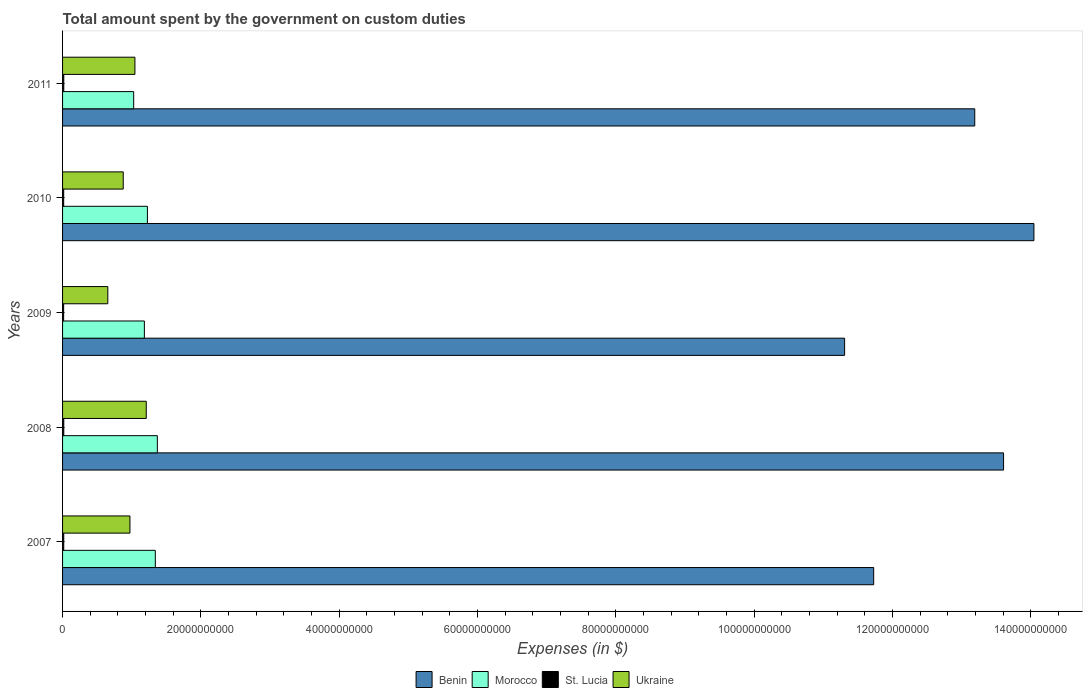How many bars are there on the 3rd tick from the top?
Keep it short and to the point. 4. How many bars are there on the 5th tick from the bottom?
Make the answer very short. 4. What is the amount spent on custom duties by the government in Benin in 2009?
Offer a very short reply. 1.13e+11. Across all years, what is the maximum amount spent on custom duties by the government in St. Lucia?
Your answer should be very brief. 1.75e+08. Across all years, what is the minimum amount spent on custom duties by the government in St. Lucia?
Give a very brief answer. 1.55e+08. In which year was the amount spent on custom duties by the government in Morocco maximum?
Your response must be concise. 2008. What is the total amount spent on custom duties by the government in Ukraine in the graph?
Ensure brevity in your answer.  4.76e+1. What is the difference between the amount spent on custom duties by the government in Morocco in 2007 and that in 2009?
Your answer should be compact. 1.59e+09. What is the difference between the amount spent on custom duties by the government in Benin in 2010 and the amount spent on custom duties by the government in St. Lucia in 2011?
Your response must be concise. 1.40e+11. What is the average amount spent on custom duties by the government in Morocco per year?
Ensure brevity in your answer.  1.23e+1. In the year 2007, what is the difference between the amount spent on custom duties by the government in St. Lucia and amount spent on custom duties by the government in Benin?
Keep it short and to the point. -1.17e+11. In how many years, is the amount spent on custom duties by the government in Ukraine greater than 84000000000 $?
Provide a succinct answer. 0. What is the ratio of the amount spent on custom duties by the government in Morocco in 2008 to that in 2009?
Keep it short and to the point. 1.16. Is the amount spent on custom duties by the government in Benin in 2007 less than that in 2009?
Ensure brevity in your answer.  No. Is the difference between the amount spent on custom duties by the government in St. Lucia in 2007 and 2011 greater than the difference between the amount spent on custom duties by the government in Benin in 2007 and 2011?
Give a very brief answer. Yes. What is the difference between the highest and the second highest amount spent on custom duties by the government in Morocco?
Provide a short and direct response. 2.91e+08. What is the difference between the highest and the lowest amount spent on custom duties by the government in Ukraine?
Provide a short and direct response. 5.56e+09. Is the sum of the amount spent on custom duties by the government in Morocco in 2008 and 2009 greater than the maximum amount spent on custom duties by the government in Benin across all years?
Provide a succinct answer. No. What does the 3rd bar from the top in 2011 represents?
Provide a succinct answer. Morocco. What does the 3rd bar from the bottom in 2009 represents?
Ensure brevity in your answer.  St. Lucia. Is it the case that in every year, the sum of the amount spent on custom duties by the government in St. Lucia and amount spent on custom duties by the government in Morocco is greater than the amount spent on custom duties by the government in Benin?
Provide a short and direct response. No. How many bars are there?
Ensure brevity in your answer.  20. Are all the bars in the graph horizontal?
Provide a short and direct response. Yes. What is the difference between two consecutive major ticks on the X-axis?
Give a very brief answer. 2.00e+1. Where does the legend appear in the graph?
Make the answer very short. Bottom center. How are the legend labels stacked?
Your response must be concise. Horizontal. What is the title of the graph?
Your response must be concise. Total amount spent by the government on custom duties. What is the label or title of the X-axis?
Offer a terse response. Expenses (in $). What is the label or title of the Y-axis?
Your answer should be very brief. Years. What is the Expenses (in $) of Benin in 2007?
Keep it short and to the point. 1.17e+11. What is the Expenses (in $) in Morocco in 2007?
Your answer should be compact. 1.34e+1. What is the Expenses (in $) in St. Lucia in 2007?
Provide a succinct answer. 1.72e+08. What is the Expenses (in $) of Ukraine in 2007?
Provide a succinct answer. 9.74e+09. What is the Expenses (in $) of Benin in 2008?
Keep it short and to the point. 1.36e+11. What is the Expenses (in $) in Morocco in 2008?
Provide a succinct answer. 1.37e+1. What is the Expenses (in $) in St. Lucia in 2008?
Your answer should be compact. 1.75e+08. What is the Expenses (in $) of Ukraine in 2008?
Your answer should be compact. 1.21e+1. What is the Expenses (in $) in Benin in 2009?
Make the answer very short. 1.13e+11. What is the Expenses (in $) in Morocco in 2009?
Your answer should be very brief. 1.18e+1. What is the Expenses (in $) of St. Lucia in 2009?
Provide a short and direct response. 1.55e+08. What is the Expenses (in $) of Ukraine in 2009?
Provide a short and direct response. 6.54e+09. What is the Expenses (in $) of Benin in 2010?
Offer a very short reply. 1.40e+11. What is the Expenses (in $) in Morocco in 2010?
Keep it short and to the point. 1.23e+1. What is the Expenses (in $) of St. Lucia in 2010?
Give a very brief answer. 1.61e+08. What is the Expenses (in $) of Ukraine in 2010?
Give a very brief answer. 8.77e+09. What is the Expenses (in $) of Benin in 2011?
Offer a very short reply. 1.32e+11. What is the Expenses (in $) of Morocco in 2011?
Offer a terse response. 1.03e+1. What is the Expenses (in $) in St. Lucia in 2011?
Ensure brevity in your answer.  1.75e+08. What is the Expenses (in $) in Ukraine in 2011?
Offer a terse response. 1.05e+1. Across all years, what is the maximum Expenses (in $) in Benin?
Keep it short and to the point. 1.40e+11. Across all years, what is the maximum Expenses (in $) in Morocco?
Give a very brief answer. 1.37e+1. Across all years, what is the maximum Expenses (in $) of St. Lucia?
Give a very brief answer. 1.75e+08. Across all years, what is the maximum Expenses (in $) of Ukraine?
Ensure brevity in your answer.  1.21e+1. Across all years, what is the minimum Expenses (in $) in Benin?
Ensure brevity in your answer.  1.13e+11. Across all years, what is the minimum Expenses (in $) of Morocco?
Give a very brief answer. 1.03e+1. Across all years, what is the minimum Expenses (in $) of St. Lucia?
Make the answer very short. 1.55e+08. Across all years, what is the minimum Expenses (in $) of Ukraine?
Provide a short and direct response. 6.54e+09. What is the total Expenses (in $) of Benin in the graph?
Offer a very short reply. 6.39e+11. What is the total Expenses (in $) of Morocco in the graph?
Give a very brief answer. 6.15e+1. What is the total Expenses (in $) of St. Lucia in the graph?
Offer a terse response. 8.38e+08. What is the total Expenses (in $) of Ukraine in the graph?
Give a very brief answer. 4.76e+1. What is the difference between the Expenses (in $) of Benin in 2007 and that in 2008?
Your answer should be very brief. -1.88e+1. What is the difference between the Expenses (in $) of Morocco in 2007 and that in 2008?
Offer a terse response. -2.91e+08. What is the difference between the Expenses (in $) of St. Lucia in 2007 and that in 2008?
Ensure brevity in your answer.  -3.30e+06. What is the difference between the Expenses (in $) of Ukraine in 2007 and that in 2008?
Make the answer very short. -2.36e+09. What is the difference between the Expenses (in $) in Benin in 2007 and that in 2009?
Offer a very short reply. 4.21e+09. What is the difference between the Expenses (in $) of Morocco in 2007 and that in 2009?
Ensure brevity in your answer.  1.59e+09. What is the difference between the Expenses (in $) of St. Lucia in 2007 and that in 2009?
Give a very brief answer. 1.72e+07. What is the difference between the Expenses (in $) of Ukraine in 2007 and that in 2009?
Offer a terse response. 3.20e+09. What is the difference between the Expenses (in $) of Benin in 2007 and that in 2010?
Your answer should be very brief. -2.32e+1. What is the difference between the Expenses (in $) in Morocco in 2007 and that in 2010?
Provide a succinct answer. 1.15e+09. What is the difference between the Expenses (in $) of St. Lucia in 2007 and that in 2010?
Offer a terse response. 1.10e+07. What is the difference between the Expenses (in $) in Ukraine in 2007 and that in 2010?
Provide a short and direct response. 9.71e+08. What is the difference between the Expenses (in $) in Benin in 2007 and that in 2011?
Make the answer very short. -1.46e+1. What is the difference between the Expenses (in $) in Morocco in 2007 and that in 2011?
Your response must be concise. 3.13e+09. What is the difference between the Expenses (in $) in St. Lucia in 2007 and that in 2011?
Make the answer very short. -2.60e+06. What is the difference between the Expenses (in $) in Ukraine in 2007 and that in 2011?
Provide a short and direct response. -7.19e+08. What is the difference between the Expenses (in $) in Benin in 2008 and that in 2009?
Give a very brief answer. 2.30e+1. What is the difference between the Expenses (in $) of Morocco in 2008 and that in 2009?
Offer a terse response. 1.88e+09. What is the difference between the Expenses (in $) in St. Lucia in 2008 and that in 2009?
Make the answer very short. 2.05e+07. What is the difference between the Expenses (in $) of Ukraine in 2008 and that in 2009?
Your answer should be very brief. 5.56e+09. What is the difference between the Expenses (in $) of Benin in 2008 and that in 2010?
Keep it short and to the point. -4.39e+09. What is the difference between the Expenses (in $) of Morocco in 2008 and that in 2010?
Give a very brief answer. 1.44e+09. What is the difference between the Expenses (in $) of St. Lucia in 2008 and that in 2010?
Your answer should be very brief. 1.43e+07. What is the difference between the Expenses (in $) in Ukraine in 2008 and that in 2010?
Keep it short and to the point. 3.33e+09. What is the difference between the Expenses (in $) in Benin in 2008 and that in 2011?
Your answer should be very brief. 4.17e+09. What is the difference between the Expenses (in $) of Morocco in 2008 and that in 2011?
Keep it short and to the point. 3.42e+09. What is the difference between the Expenses (in $) of Ukraine in 2008 and that in 2011?
Offer a very short reply. 1.64e+09. What is the difference between the Expenses (in $) in Benin in 2009 and that in 2010?
Keep it short and to the point. -2.74e+1. What is the difference between the Expenses (in $) of Morocco in 2009 and that in 2010?
Your response must be concise. -4.39e+08. What is the difference between the Expenses (in $) in St. Lucia in 2009 and that in 2010?
Keep it short and to the point. -6.20e+06. What is the difference between the Expenses (in $) of Ukraine in 2009 and that in 2010?
Make the answer very short. -2.23e+09. What is the difference between the Expenses (in $) of Benin in 2009 and that in 2011?
Provide a short and direct response. -1.88e+1. What is the difference between the Expenses (in $) in Morocco in 2009 and that in 2011?
Give a very brief answer. 1.54e+09. What is the difference between the Expenses (in $) of St. Lucia in 2009 and that in 2011?
Your answer should be compact. -1.98e+07. What is the difference between the Expenses (in $) of Ukraine in 2009 and that in 2011?
Your response must be concise. -3.92e+09. What is the difference between the Expenses (in $) in Benin in 2010 and that in 2011?
Offer a terse response. 8.56e+09. What is the difference between the Expenses (in $) in Morocco in 2010 and that in 2011?
Offer a very short reply. 1.98e+09. What is the difference between the Expenses (in $) in St. Lucia in 2010 and that in 2011?
Give a very brief answer. -1.36e+07. What is the difference between the Expenses (in $) in Ukraine in 2010 and that in 2011?
Your answer should be compact. -1.69e+09. What is the difference between the Expenses (in $) in Benin in 2007 and the Expenses (in $) in Morocco in 2008?
Offer a terse response. 1.04e+11. What is the difference between the Expenses (in $) of Benin in 2007 and the Expenses (in $) of St. Lucia in 2008?
Your answer should be very brief. 1.17e+11. What is the difference between the Expenses (in $) in Benin in 2007 and the Expenses (in $) in Ukraine in 2008?
Your response must be concise. 1.05e+11. What is the difference between the Expenses (in $) in Morocco in 2007 and the Expenses (in $) in St. Lucia in 2008?
Provide a short and direct response. 1.32e+1. What is the difference between the Expenses (in $) of Morocco in 2007 and the Expenses (in $) of Ukraine in 2008?
Give a very brief answer. 1.31e+09. What is the difference between the Expenses (in $) of St. Lucia in 2007 and the Expenses (in $) of Ukraine in 2008?
Ensure brevity in your answer.  -1.19e+1. What is the difference between the Expenses (in $) of Benin in 2007 and the Expenses (in $) of Morocco in 2009?
Your answer should be compact. 1.05e+11. What is the difference between the Expenses (in $) of Benin in 2007 and the Expenses (in $) of St. Lucia in 2009?
Your answer should be compact. 1.17e+11. What is the difference between the Expenses (in $) of Benin in 2007 and the Expenses (in $) of Ukraine in 2009?
Provide a short and direct response. 1.11e+11. What is the difference between the Expenses (in $) in Morocco in 2007 and the Expenses (in $) in St. Lucia in 2009?
Ensure brevity in your answer.  1.33e+1. What is the difference between the Expenses (in $) in Morocco in 2007 and the Expenses (in $) in Ukraine in 2009?
Your response must be concise. 6.87e+09. What is the difference between the Expenses (in $) of St. Lucia in 2007 and the Expenses (in $) of Ukraine in 2009?
Your answer should be compact. -6.37e+09. What is the difference between the Expenses (in $) of Benin in 2007 and the Expenses (in $) of Morocco in 2010?
Ensure brevity in your answer.  1.05e+11. What is the difference between the Expenses (in $) of Benin in 2007 and the Expenses (in $) of St. Lucia in 2010?
Make the answer very short. 1.17e+11. What is the difference between the Expenses (in $) of Benin in 2007 and the Expenses (in $) of Ukraine in 2010?
Your answer should be very brief. 1.09e+11. What is the difference between the Expenses (in $) of Morocco in 2007 and the Expenses (in $) of St. Lucia in 2010?
Provide a succinct answer. 1.33e+1. What is the difference between the Expenses (in $) of Morocco in 2007 and the Expenses (in $) of Ukraine in 2010?
Keep it short and to the point. 4.64e+09. What is the difference between the Expenses (in $) in St. Lucia in 2007 and the Expenses (in $) in Ukraine in 2010?
Keep it short and to the point. -8.60e+09. What is the difference between the Expenses (in $) of Benin in 2007 and the Expenses (in $) of Morocco in 2011?
Provide a succinct answer. 1.07e+11. What is the difference between the Expenses (in $) in Benin in 2007 and the Expenses (in $) in St. Lucia in 2011?
Ensure brevity in your answer.  1.17e+11. What is the difference between the Expenses (in $) of Benin in 2007 and the Expenses (in $) of Ukraine in 2011?
Make the answer very short. 1.07e+11. What is the difference between the Expenses (in $) of Morocco in 2007 and the Expenses (in $) of St. Lucia in 2011?
Offer a very short reply. 1.32e+1. What is the difference between the Expenses (in $) of Morocco in 2007 and the Expenses (in $) of Ukraine in 2011?
Give a very brief answer. 2.95e+09. What is the difference between the Expenses (in $) in St. Lucia in 2007 and the Expenses (in $) in Ukraine in 2011?
Make the answer very short. -1.03e+1. What is the difference between the Expenses (in $) of Benin in 2008 and the Expenses (in $) of Morocco in 2009?
Make the answer very short. 1.24e+11. What is the difference between the Expenses (in $) in Benin in 2008 and the Expenses (in $) in St. Lucia in 2009?
Your answer should be compact. 1.36e+11. What is the difference between the Expenses (in $) of Benin in 2008 and the Expenses (in $) of Ukraine in 2009?
Ensure brevity in your answer.  1.30e+11. What is the difference between the Expenses (in $) in Morocco in 2008 and the Expenses (in $) in St. Lucia in 2009?
Your answer should be very brief. 1.36e+1. What is the difference between the Expenses (in $) in Morocco in 2008 and the Expenses (in $) in Ukraine in 2009?
Your answer should be very brief. 7.16e+09. What is the difference between the Expenses (in $) of St. Lucia in 2008 and the Expenses (in $) of Ukraine in 2009?
Ensure brevity in your answer.  -6.37e+09. What is the difference between the Expenses (in $) in Benin in 2008 and the Expenses (in $) in Morocco in 2010?
Keep it short and to the point. 1.24e+11. What is the difference between the Expenses (in $) in Benin in 2008 and the Expenses (in $) in St. Lucia in 2010?
Ensure brevity in your answer.  1.36e+11. What is the difference between the Expenses (in $) in Benin in 2008 and the Expenses (in $) in Ukraine in 2010?
Provide a succinct answer. 1.27e+11. What is the difference between the Expenses (in $) in Morocco in 2008 and the Expenses (in $) in St. Lucia in 2010?
Provide a short and direct response. 1.35e+1. What is the difference between the Expenses (in $) of Morocco in 2008 and the Expenses (in $) of Ukraine in 2010?
Your answer should be very brief. 4.93e+09. What is the difference between the Expenses (in $) in St. Lucia in 2008 and the Expenses (in $) in Ukraine in 2010?
Offer a terse response. -8.60e+09. What is the difference between the Expenses (in $) of Benin in 2008 and the Expenses (in $) of Morocco in 2011?
Offer a terse response. 1.26e+11. What is the difference between the Expenses (in $) of Benin in 2008 and the Expenses (in $) of St. Lucia in 2011?
Provide a succinct answer. 1.36e+11. What is the difference between the Expenses (in $) of Benin in 2008 and the Expenses (in $) of Ukraine in 2011?
Give a very brief answer. 1.26e+11. What is the difference between the Expenses (in $) of Morocco in 2008 and the Expenses (in $) of St. Lucia in 2011?
Make the answer very short. 1.35e+1. What is the difference between the Expenses (in $) in Morocco in 2008 and the Expenses (in $) in Ukraine in 2011?
Keep it short and to the point. 3.24e+09. What is the difference between the Expenses (in $) of St. Lucia in 2008 and the Expenses (in $) of Ukraine in 2011?
Provide a short and direct response. -1.03e+1. What is the difference between the Expenses (in $) of Benin in 2009 and the Expenses (in $) of Morocco in 2010?
Ensure brevity in your answer.  1.01e+11. What is the difference between the Expenses (in $) in Benin in 2009 and the Expenses (in $) in St. Lucia in 2010?
Ensure brevity in your answer.  1.13e+11. What is the difference between the Expenses (in $) of Benin in 2009 and the Expenses (in $) of Ukraine in 2010?
Make the answer very short. 1.04e+11. What is the difference between the Expenses (in $) of Morocco in 2009 and the Expenses (in $) of St. Lucia in 2010?
Your response must be concise. 1.17e+1. What is the difference between the Expenses (in $) in Morocco in 2009 and the Expenses (in $) in Ukraine in 2010?
Offer a terse response. 3.06e+09. What is the difference between the Expenses (in $) in St. Lucia in 2009 and the Expenses (in $) in Ukraine in 2010?
Your answer should be very brief. -8.62e+09. What is the difference between the Expenses (in $) in Benin in 2009 and the Expenses (in $) in Morocco in 2011?
Provide a succinct answer. 1.03e+11. What is the difference between the Expenses (in $) in Benin in 2009 and the Expenses (in $) in St. Lucia in 2011?
Keep it short and to the point. 1.13e+11. What is the difference between the Expenses (in $) of Benin in 2009 and the Expenses (in $) of Ukraine in 2011?
Give a very brief answer. 1.03e+11. What is the difference between the Expenses (in $) of Morocco in 2009 and the Expenses (in $) of St. Lucia in 2011?
Make the answer very short. 1.17e+1. What is the difference between the Expenses (in $) in Morocco in 2009 and the Expenses (in $) in Ukraine in 2011?
Offer a terse response. 1.37e+09. What is the difference between the Expenses (in $) of St. Lucia in 2009 and the Expenses (in $) of Ukraine in 2011?
Ensure brevity in your answer.  -1.03e+1. What is the difference between the Expenses (in $) of Benin in 2010 and the Expenses (in $) of Morocco in 2011?
Ensure brevity in your answer.  1.30e+11. What is the difference between the Expenses (in $) in Benin in 2010 and the Expenses (in $) in St. Lucia in 2011?
Provide a succinct answer. 1.40e+11. What is the difference between the Expenses (in $) in Benin in 2010 and the Expenses (in $) in Ukraine in 2011?
Keep it short and to the point. 1.30e+11. What is the difference between the Expenses (in $) in Morocco in 2010 and the Expenses (in $) in St. Lucia in 2011?
Give a very brief answer. 1.21e+1. What is the difference between the Expenses (in $) in Morocco in 2010 and the Expenses (in $) in Ukraine in 2011?
Offer a terse response. 1.81e+09. What is the difference between the Expenses (in $) of St. Lucia in 2010 and the Expenses (in $) of Ukraine in 2011?
Give a very brief answer. -1.03e+1. What is the average Expenses (in $) in Benin per year?
Your response must be concise. 1.28e+11. What is the average Expenses (in $) of Morocco per year?
Give a very brief answer. 1.23e+1. What is the average Expenses (in $) in St. Lucia per year?
Ensure brevity in your answer.  1.68e+08. What is the average Expenses (in $) in Ukraine per year?
Your response must be concise. 9.52e+09. In the year 2007, what is the difference between the Expenses (in $) in Benin and Expenses (in $) in Morocco?
Offer a terse response. 1.04e+11. In the year 2007, what is the difference between the Expenses (in $) in Benin and Expenses (in $) in St. Lucia?
Offer a terse response. 1.17e+11. In the year 2007, what is the difference between the Expenses (in $) in Benin and Expenses (in $) in Ukraine?
Provide a succinct answer. 1.08e+11. In the year 2007, what is the difference between the Expenses (in $) in Morocco and Expenses (in $) in St. Lucia?
Provide a succinct answer. 1.32e+1. In the year 2007, what is the difference between the Expenses (in $) in Morocco and Expenses (in $) in Ukraine?
Make the answer very short. 3.67e+09. In the year 2007, what is the difference between the Expenses (in $) in St. Lucia and Expenses (in $) in Ukraine?
Your answer should be very brief. -9.57e+09. In the year 2008, what is the difference between the Expenses (in $) in Benin and Expenses (in $) in Morocco?
Give a very brief answer. 1.22e+11. In the year 2008, what is the difference between the Expenses (in $) of Benin and Expenses (in $) of St. Lucia?
Give a very brief answer. 1.36e+11. In the year 2008, what is the difference between the Expenses (in $) of Benin and Expenses (in $) of Ukraine?
Your answer should be compact. 1.24e+11. In the year 2008, what is the difference between the Expenses (in $) in Morocco and Expenses (in $) in St. Lucia?
Keep it short and to the point. 1.35e+1. In the year 2008, what is the difference between the Expenses (in $) in Morocco and Expenses (in $) in Ukraine?
Provide a succinct answer. 1.60e+09. In the year 2008, what is the difference between the Expenses (in $) of St. Lucia and Expenses (in $) of Ukraine?
Keep it short and to the point. -1.19e+1. In the year 2009, what is the difference between the Expenses (in $) in Benin and Expenses (in $) in Morocco?
Keep it short and to the point. 1.01e+11. In the year 2009, what is the difference between the Expenses (in $) in Benin and Expenses (in $) in St. Lucia?
Offer a terse response. 1.13e+11. In the year 2009, what is the difference between the Expenses (in $) in Benin and Expenses (in $) in Ukraine?
Ensure brevity in your answer.  1.07e+11. In the year 2009, what is the difference between the Expenses (in $) of Morocco and Expenses (in $) of St. Lucia?
Offer a terse response. 1.17e+1. In the year 2009, what is the difference between the Expenses (in $) in Morocco and Expenses (in $) in Ukraine?
Your answer should be very brief. 5.29e+09. In the year 2009, what is the difference between the Expenses (in $) of St. Lucia and Expenses (in $) of Ukraine?
Make the answer very short. -6.39e+09. In the year 2010, what is the difference between the Expenses (in $) of Benin and Expenses (in $) of Morocco?
Provide a succinct answer. 1.28e+11. In the year 2010, what is the difference between the Expenses (in $) of Benin and Expenses (in $) of St. Lucia?
Provide a short and direct response. 1.40e+11. In the year 2010, what is the difference between the Expenses (in $) of Benin and Expenses (in $) of Ukraine?
Offer a very short reply. 1.32e+11. In the year 2010, what is the difference between the Expenses (in $) of Morocco and Expenses (in $) of St. Lucia?
Provide a succinct answer. 1.21e+1. In the year 2010, what is the difference between the Expenses (in $) in Morocco and Expenses (in $) in Ukraine?
Provide a short and direct response. 3.50e+09. In the year 2010, what is the difference between the Expenses (in $) in St. Lucia and Expenses (in $) in Ukraine?
Make the answer very short. -8.61e+09. In the year 2011, what is the difference between the Expenses (in $) in Benin and Expenses (in $) in Morocco?
Provide a succinct answer. 1.22e+11. In the year 2011, what is the difference between the Expenses (in $) in Benin and Expenses (in $) in St. Lucia?
Give a very brief answer. 1.32e+11. In the year 2011, what is the difference between the Expenses (in $) in Benin and Expenses (in $) in Ukraine?
Your answer should be very brief. 1.21e+11. In the year 2011, what is the difference between the Expenses (in $) of Morocco and Expenses (in $) of St. Lucia?
Keep it short and to the point. 1.01e+1. In the year 2011, what is the difference between the Expenses (in $) of Morocco and Expenses (in $) of Ukraine?
Your answer should be very brief. -1.77e+08. In the year 2011, what is the difference between the Expenses (in $) in St. Lucia and Expenses (in $) in Ukraine?
Make the answer very short. -1.03e+1. What is the ratio of the Expenses (in $) in Benin in 2007 to that in 2008?
Offer a very short reply. 0.86. What is the ratio of the Expenses (in $) of Morocco in 2007 to that in 2008?
Your answer should be very brief. 0.98. What is the ratio of the Expenses (in $) in St. Lucia in 2007 to that in 2008?
Give a very brief answer. 0.98. What is the ratio of the Expenses (in $) of Ukraine in 2007 to that in 2008?
Your answer should be compact. 0.81. What is the ratio of the Expenses (in $) in Benin in 2007 to that in 2009?
Your answer should be compact. 1.04. What is the ratio of the Expenses (in $) of Morocco in 2007 to that in 2009?
Make the answer very short. 1.13. What is the ratio of the Expenses (in $) of St. Lucia in 2007 to that in 2009?
Make the answer very short. 1.11. What is the ratio of the Expenses (in $) in Ukraine in 2007 to that in 2009?
Keep it short and to the point. 1.49. What is the ratio of the Expenses (in $) of Benin in 2007 to that in 2010?
Your answer should be very brief. 0.83. What is the ratio of the Expenses (in $) in Morocco in 2007 to that in 2010?
Offer a terse response. 1.09. What is the ratio of the Expenses (in $) in St. Lucia in 2007 to that in 2010?
Keep it short and to the point. 1.07. What is the ratio of the Expenses (in $) in Ukraine in 2007 to that in 2010?
Provide a succinct answer. 1.11. What is the ratio of the Expenses (in $) of Benin in 2007 to that in 2011?
Provide a short and direct response. 0.89. What is the ratio of the Expenses (in $) in Morocco in 2007 to that in 2011?
Give a very brief answer. 1.3. What is the ratio of the Expenses (in $) of St. Lucia in 2007 to that in 2011?
Offer a terse response. 0.99. What is the ratio of the Expenses (in $) of Ukraine in 2007 to that in 2011?
Your response must be concise. 0.93. What is the ratio of the Expenses (in $) in Benin in 2008 to that in 2009?
Provide a succinct answer. 1.2. What is the ratio of the Expenses (in $) in Morocco in 2008 to that in 2009?
Your answer should be very brief. 1.16. What is the ratio of the Expenses (in $) of St. Lucia in 2008 to that in 2009?
Provide a short and direct response. 1.13. What is the ratio of the Expenses (in $) of Ukraine in 2008 to that in 2009?
Your answer should be very brief. 1.85. What is the ratio of the Expenses (in $) of Benin in 2008 to that in 2010?
Offer a terse response. 0.97. What is the ratio of the Expenses (in $) in Morocco in 2008 to that in 2010?
Your answer should be compact. 1.12. What is the ratio of the Expenses (in $) of St. Lucia in 2008 to that in 2010?
Provide a succinct answer. 1.09. What is the ratio of the Expenses (in $) in Ukraine in 2008 to that in 2010?
Make the answer very short. 1.38. What is the ratio of the Expenses (in $) in Benin in 2008 to that in 2011?
Your response must be concise. 1.03. What is the ratio of the Expenses (in $) of Morocco in 2008 to that in 2011?
Give a very brief answer. 1.33. What is the ratio of the Expenses (in $) in St. Lucia in 2008 to that in 2011?
Offer a very short reply. 1. What is the ratio of the Expenses (in $) in Ukraine in 2008 to that in 2011?
Your response must be concise. 1.16. What is the ratio of the Expenses (in $) in Benin in 2009 to that in 2010?
Make the answer very short. 0.81. What is the ratio of the Expenses (in $) in Morocco in 2009 to that in 2010?
Your answer should be compact. 0.96. What is the ratio of the Expenses (in $) in St. Lucia in 2009 to that in 2010?
Offer a terse response. 0.96. What is the ratio of the Expenses (in $) of Ukraine in 2009 to that in 2010?
Ensure brevity in your answer.  0.75. What is the ratio of the Expenses (in $) of Benin in 2009 to that in 2011?
Your answer should be compact. 0.86. What is the ratio of the Expenses (in $) of Morocco in 2009 to that in 2011?
Provide a succinct answer. 1.15. What is the ratio of the Expenses (in $) in St. Lucia in 2009 to that in 2011?
Provide a short and direct response. 0.89. What is the ratio of the Expenses (in $) of Ukraine in 2009 to that in 2011?
Ensure brevity in your answer.  0.63. What is the ratio of the Expenses (in $) of Benin in 2010 to that in 2011?
Your response must be concise. 1.06. What is the ratio of the Expenses (in $) of Morocco in 2010 to that in 2011?
Provide a succinct answer. 1.19. What is the ratio of the Expenses (in $) in St. Lucia in 2010 to that in 2011?
Make the answer very short. 0.92. What is the ratio of the Expenses (in $) in Ukraine in 2010 to that in 2011?
Offer a terse response. 0.84. What is the difference between the highest and the second highest Expenses (in $) in Benin?
Offer a very short reply. 4.39e+09. What is the difference between the highest and the second highest Expenses (in $) in Morocco?
Make the answer very short. 2.91e+08. What is the difference between the highest and the second highest Expenses (in $) of Ukraine?
Give a very brief answer. 1.64e+09. What is the difference between the highest and the lowest Expenses (in $) of Benin?
Make the answer very short. 2.74e+1. What is the difference between the highest and the lowest Expenses (in $) of Morocco?
Your response must be concise. 3.42e+09. What is the difference between the highest and the lowest Expenses (in $) in St. Lucia?
Your answer should be very brief. 2.05e+07. What is the difference between the highest and the lowest Expenses (in $) of Ukraine?
Your response must be concise. 5.56e+09. 